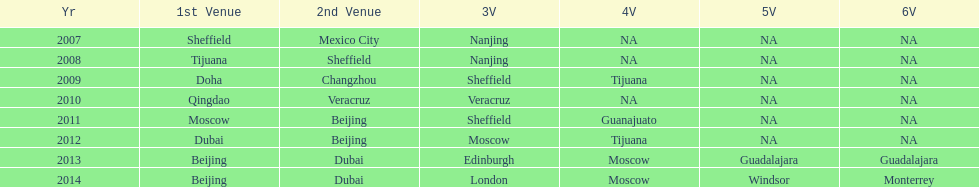In list of venues, how many years was beijing above moscow (1st venue is above 2nd venue, etc)? 3. 